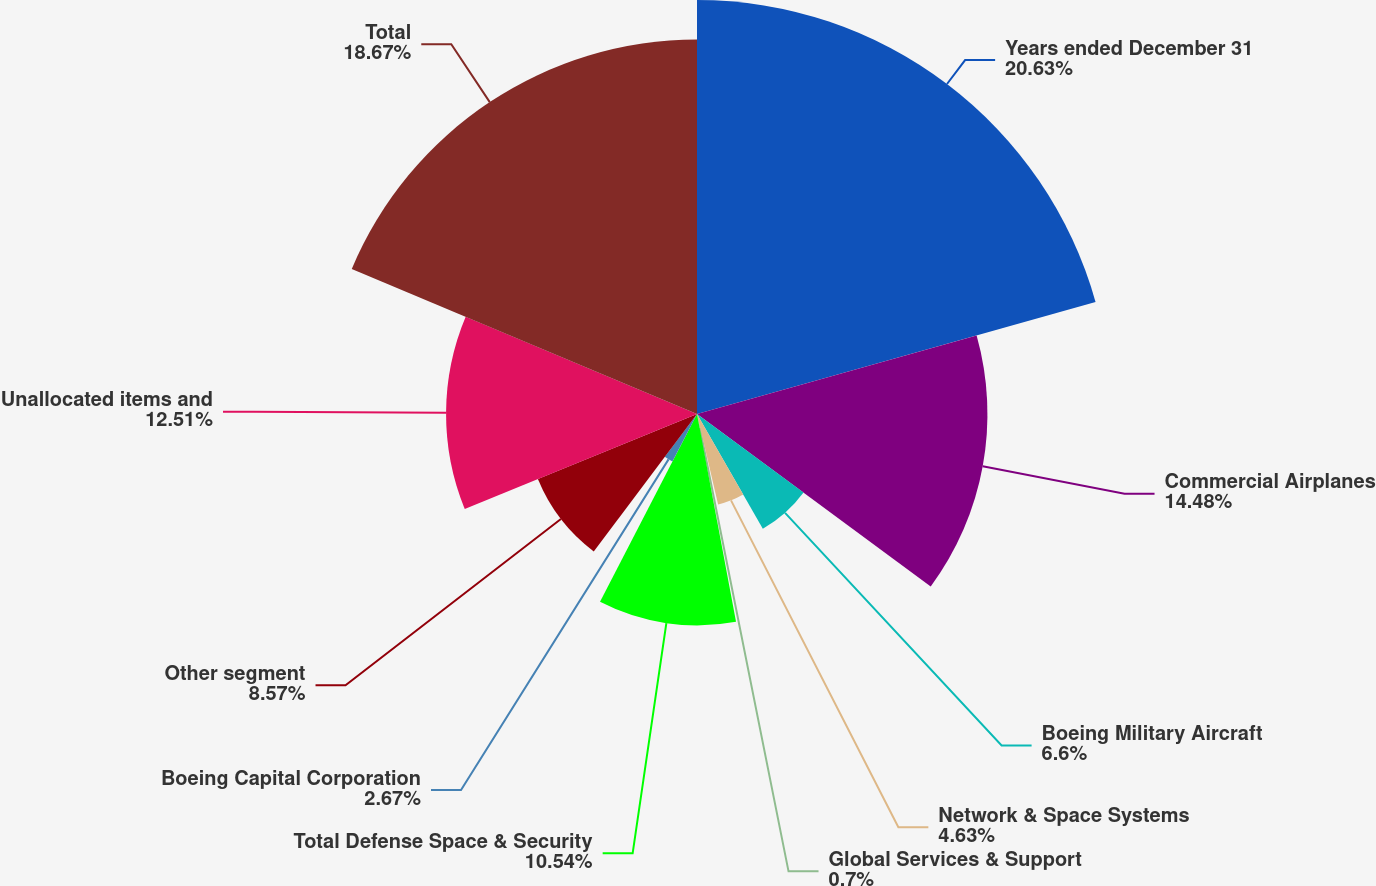<chart> <loc_0><loc_0><loc_500><loc_500><pie_chart><fcel>Years ended December 31<fcel>Commercial Airplanes<fcel>Boeing Military Aircraft<fcel>Network & Space Systems<fcel>Global Services & Support<fcel>Total Defense Space & Security<fcel>Boeing Capital Corporation<fcel>Other segment<fcel>Unallocated items and<fcel>Total<nl><fcel>20.64%<fcel>14.48%<fcel>6.6%<fcel>4.63%<fcel>0.7%<fcel>10.54%<fcel>2.67%<fcel>8.57%<fcel>12.51%<fcel>18.67%<nl></chart> 